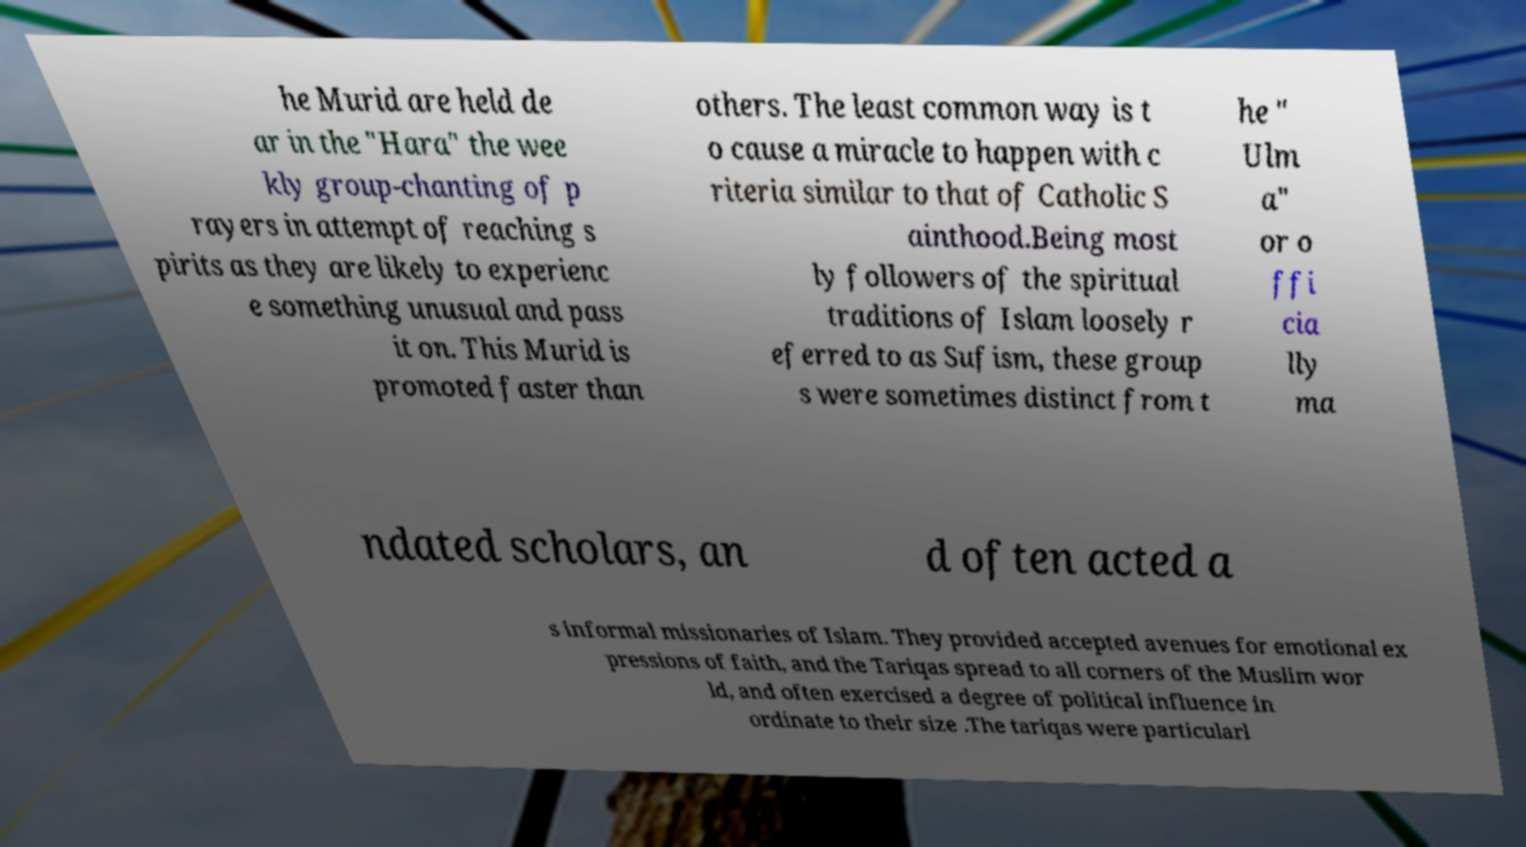What messages or text are displayed in this image? I need them in a readable, typed format. he Murid are held de ar in the "Hara" the wee kly group-chanting of p rayers in attempt of reaching s pirits as they are likely to experienc e something unusual and pass it on. This Murid is promoted faster than others. The least common way is t o cause a miracle to happen with c riteria similar to that of Catholic S ainthood.Being most ly followers of the spiritual traditions of Islam loosely r eferred to as Sufism, these group s were sometimes distinct from t he " Ulm a" or o ffi cia lly ma ndated scholars, an d often acted a s informal missionaries of Islam. They provided accepted avenues for emotional ex pressions of faith, and the Tariqas spread to all corners of the Muslim wor ld, and often exercised a degree of political influence in ordinate to their size .The tariqas were particularl 